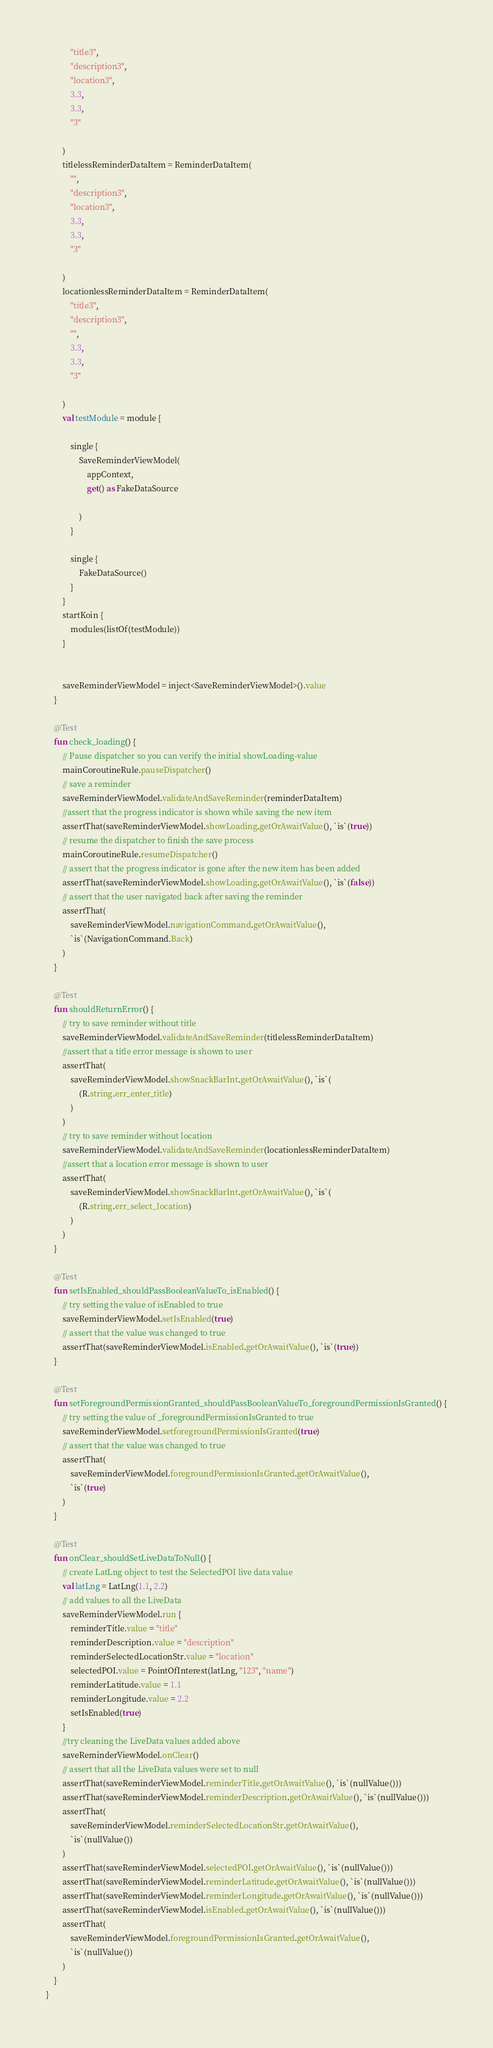<code> <loc_0><loc_0><loc_500><loc_500><_Kotlin_>            "title3",
            "description3",
            "location3",
            3.3,
            3.3,
            "3"

        )
        titlelessReminderDataItem = ReminderDataItem(
            "",
            "description3",
            "location3",
            3.3,
            3.3,
            "3"

        )
        locationlessReminderDataItem = ReminderDataItem(
            "title3",
            "description3",
            "",
            3.3,
            3.3,
            "3"

        )
        val testModule = module {

            single {
                SaveReminderViewModel(
                    appContext,
                    get() as FakeDataSource

                )
            }

            single {
                FakeDataSource()
            }
        }
        startKoin {
            modules(listOf(testModule))
        }


        saveReminderViewModel = inject<SaveReminderViewModel>().value
    }

    @Test
    fun check_loading() {
        // Pause dispatcher so you can verify the initial showLoading-value
        mainCoroutineRule.pauseDispatcher()
        // save a reminder
        saveReminderViewModel.validateAndSaveReminder(reminderDataItem)
        //assert that the progress indicator is shown while saving the new item
        assertThat(saveReminderViewModel.showLoading.getOrAwaitValue(), `is`(true))
        // resume the dispatcher to finish the save process
        mainCoroutineRule.resumeDispatcher()
        // assert that the progress indicator is gone after the new item has been added
        assertThat(saveReminderViewModel.showLoading.getOrAwaitValue(), `is`(false))
        // assert that the user navigated back after saving the reminder
        assertThat(
            saveReminderViewModel.navigationCommand.getOrAwaitValue(),
            `is`(NavigationCommand.Back)
        )
    }

    @Test
    fun shouldReturnError() {
        // try to save reminder without title
        saveReminderViewModel.validateAndSaveReminder(titlelessReminderDataItem)
        //assert that a title error message is shown to user
        assertThat(
            saveReminderViewModel.showSnackBarInt.getOrAwaitValue(), `is`(
                (R.string.err_enter_title)
            )
        )
        // try to save reminder without location
        saveReminderViewModel.validateAndSaveReminder(locationlessReminderDataItem)
        //assert that a location error message is shown to user
        assertThat(
            saveReminderViewModel.showSnackBarInt.getOrAwaitValue(), `is`(
                (R.string.err_select_location)
            )
        )
    }

    @Test
    fun setIsEnabled_shouldPassBooleanValueTo_isEnabled() {
        // try setting the value of isEnabled to true
        saveReminderViewModel.setIsEnabled(true)
        // assert that the value was changed to true
        assertThat(saveReminderViewModel.isEnabled.getOrAwaitValue(), `is`(true))
    }

    @Test
    fun setForegroundPermissionGranted_shouldPassBooleanValueTo_foregroundPermissionIsGranted() {
        // try setting the value of _foregroundPermissionIsGranted to true
        saveReminderViewModel.setforegroundPermissionIsGranted(true)
        // assert that the value was changed to true
        assertThat(
            saveReminderViewModel.foregroundPermissionIsGranted.getOrAwaitValue(),
            `is`(true)
        )
    }

    @Test
    fun onClear_shouldSetLiveDataToNull() {
        // create LatLng object to test the SelectedPOI live data value
        val latLng = LatLng(1.1, 2.2)
        // add values to all the LiveData
        saveReminderViewModel.run {
            reminderTitle.value = "title"
            reminderDescription.value = "description"
            reminderSelectedLocationStr.value = "location"
            selectedPOI.value = PointOfInterest(latLng, "123", "name")
            reminderLatitude.value = 1.1
            reminderLongitude.value = 2.2
            setIsEnabled(true)
        }
        //try cleaning the LiveData values added above
        saveReminderViewModel.onClear()
        // assert that all the LiveData values were set to null
        assertThat(saveReminderViewModel.reminderTitle.getOrAwaitValue(), `is`(nullValue()))
        assertThat(saveReminderViewModel.reminderDescription.getOrAwaitValue(), `is`(nullValue()))
        assertThat(
            saveReminderViewModel.reminderSelectedLocationStr.getOrAwaitValue(),
            `is`(nullValue())
        )
        assertThat(saveReminderViewModel.selectedPOI.getOrAwaitValue(), `is`(nullValue()))
        assertThat(saveReminderViewModel.reminderLatitude.getOrAwaitValue(), `is`(nullValue()))
        assertThat(saveReminderViewModel.reminderLongitude.getOrAwaitValue(), `is`(nullValue()))
        assertThat(saveReminderViewModel.isEnabled.getOrAwaitValue(), `is`(nullValue()))
        assertThat(
            saveReminderViewModel.foregroundPermissionIsGranted.getOrAwaitValue(),
            `is`(nullValue())
        )
    }
}</code> 